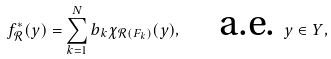<formula> <loc_0><loc_0><loc_500><loc_500>f _ { \mathcal { R } } ^ { * } ( y ) = \sum _ { k = 1 } ^ { N } b _ { k } \chi _ { \mathcal { R } ( F _ { k } ) } ( y ) , \quad \text {a.e. } y \in Y ,</formula> 